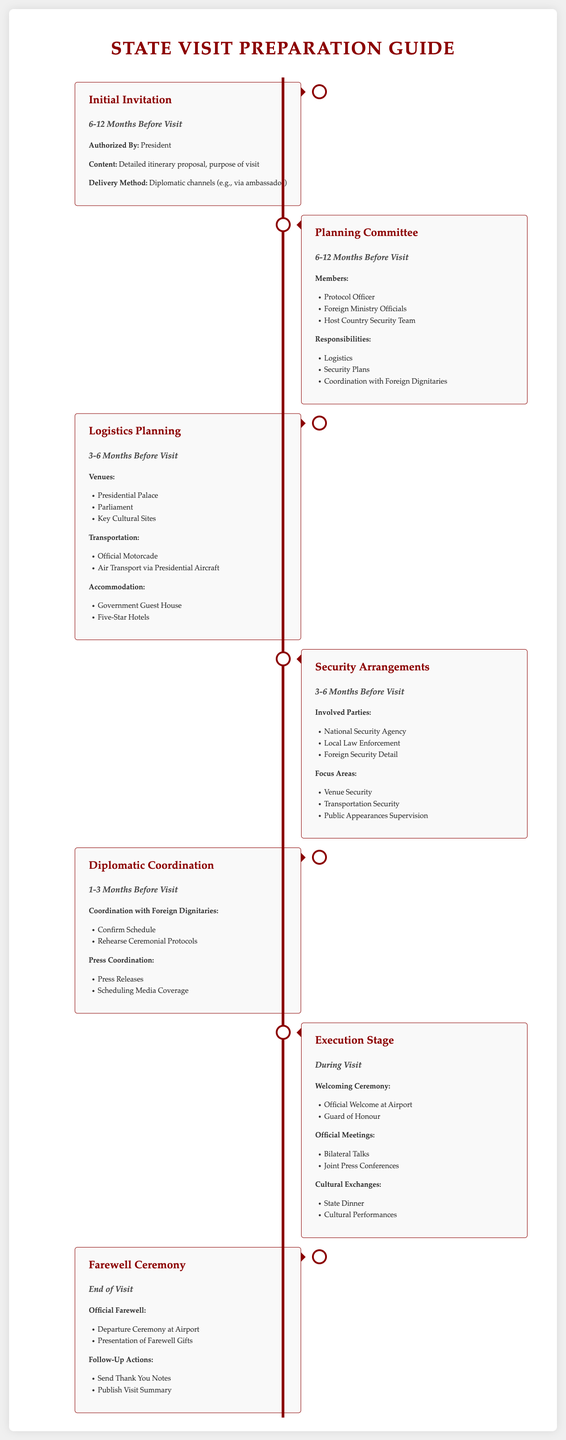What is the initial invitation timeline? The initial invitation is proposed 6-12 months before the visit.
Answer: 6-12 Months Before Visit Who approves the initial invitation? The initial invitation is authorized by the President.
Answer: President What are the members of the planning committee? The planning committee includes the Protocol Officer, Foreign Ministry Officials, and Host Country Security Team.
Answer: Protocol Officer, Foreign Ministry Officials, Host Country Security Team What is a key focus area for security arrangements? A key focus area for security arrangements is Venue Security.
Answer: Venue Security What is included in the execution stage? The execution stage includes welcoming ceremonies, official meetings, and cultural exchanges.
Answer: Welcoming Ceremony, Official Meetings, Cultural Exchanges What follow-up actions occur after the farewell ceremony? Follow-up actions include sending thank you notes and publishing a visit summary.
Answer: Send Thank You Notes, Publish Visit Summary 